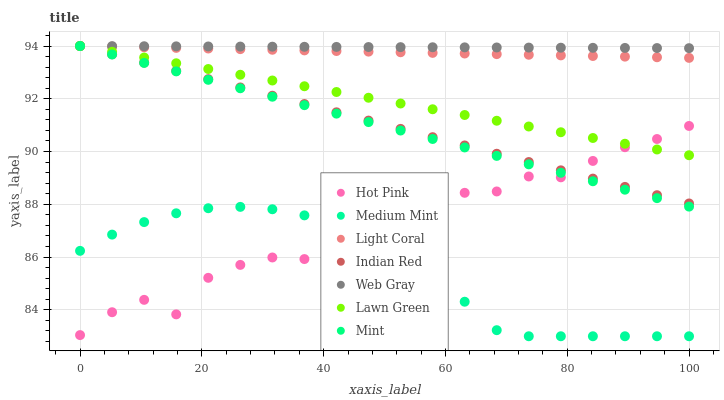Does Medium Mint have the minimum area under the curve?
Answer yes or no. Yes. Does Web Gray have the maximum area under the curve?
Answer yes or no. Yes. Does Lawn Green have the minimum area under the curve?
Answer yes or no. No. Does Lawn Green have the maximum area under the curve?
Answer yes or no. No. Is Web Gray the smoothest?
Answer yes or no. Yes. Is Hot Pink the roughest?
Answer yes or no. Yes. Is Lawn Green the smoothest?
Answer yes or no. No. Is Lawn Green the roughest?
Answer yes or no. No. Does Medium Mint have the lowest value?
Answer yes or no. Yes. Does Lawn Green have the lowest value?
Answer yes or no. No. Does Mint have the highest value?
Answer yes or no. Yes. Does Hot Pink have the highest value?
Answer yes or no. No. Is Hot Pink less than Web Gray?
Answer yes or no. Yes. Is Light Coral greater than Medium Mint?
Answer yes or no. Yes. Does Mint intersect Hot Pink?
Answer yes or no. Yes. Is Mint less than Hot Pink?
Answer yes or no. No. Is Mint greater than Hot Pink?
Answer yes or no. No. Does Hot Pink intersect Web Gray?
Answer yes or no. No. 